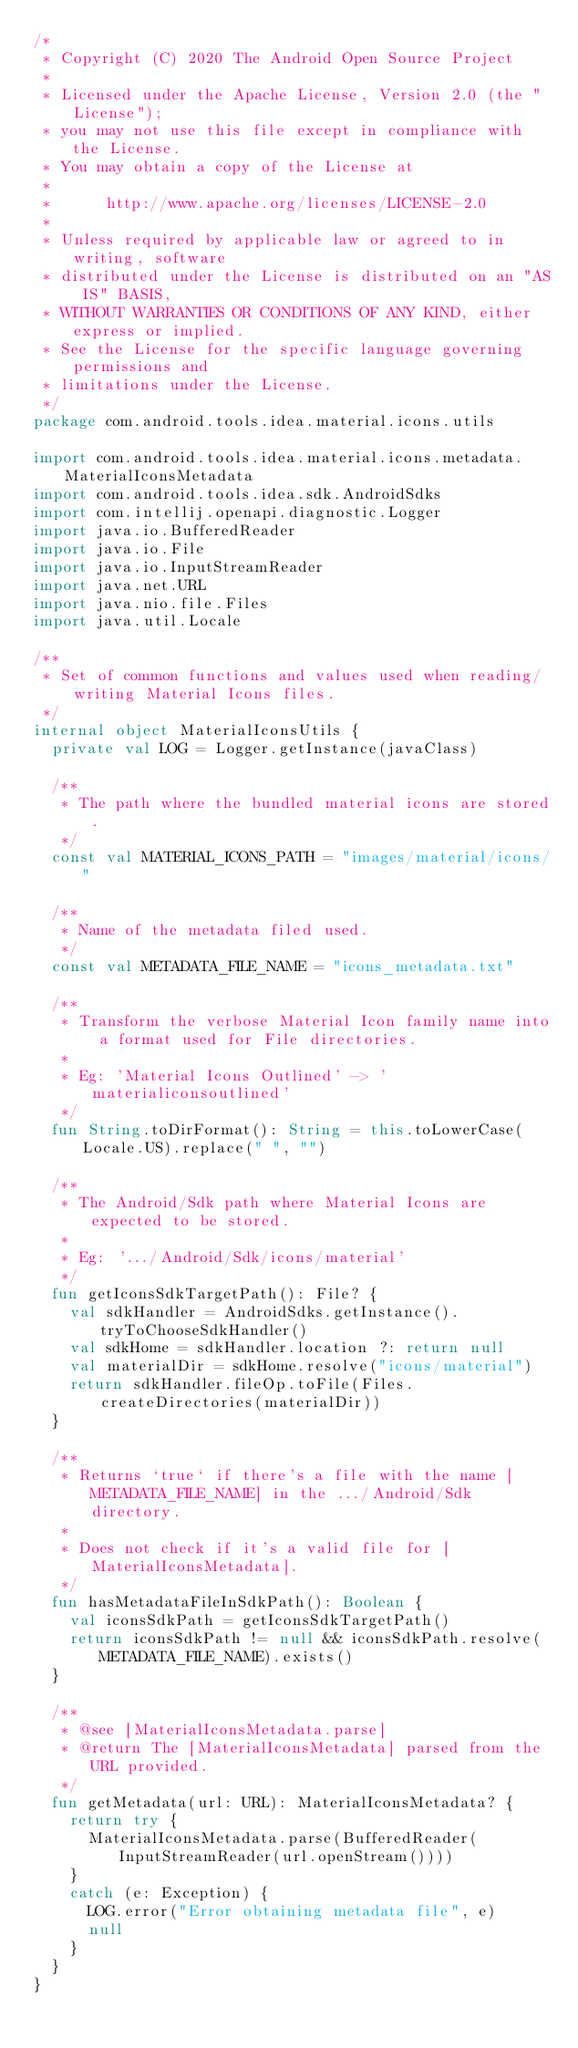Convert code to text. <code><loc_0><loc_0><loc_500><loc_500><_Kotlin_>/*
 * Copyright (C) 2020 The Android Open Source Project
 *
 * Licensed under the Apache License, Version 2.0 (the "License");
 * you may not use this file except in compliance with the License.
 * You may obtain a copy of the License at
 *
 *      http://www.apache.org/licenses/LICENSE-2.0
 *
 * Unless required by applicable law or agreed to in writing, software
 * distributed under the License is distributed on an "AS IS" BASIS,
 * WITHOUT WARRANTIES OR CONDITIONS OF ANY KIND, either express or implied.
 * See the License for the specific language governing permissions and
 * limitations under the License.
 */
package com.android.tools.idea.material.icons.utils

import com.android.tools.idea.material.icons.metadata.MaterialIconsMetadata
import com.android.tools.idea.sdk.AndroidSdks
import com.intellij.openapi.diagnostic.Logger
import java.io.BufferedReader
import java.io.File
import java.io.InputStreamReader
import java.net.URL
import java.nio.file.Files
import java.util.Locale

/**
 * Set of common functions and values used when reading/writing Material Icons files.
 */
internal object MaterialIconsUtils {
  private val LOG = Logger.getInstance(javaClass)

  /**
   * The path where the bundled material icons are stored.
   */
  const val MATERIAL_ICONS_PATH = "images/material/icons/"

  /**
   * Name of the metadata filed used.
   */
  const val METADATA_FILE_NAME = "icons_metadata.txt"

  /**
   * Transform the verbose Material Icon family name into a format used for File directories.
   *
   * Eg: 'Material Icons Outlined' -> 'materialiconsoutlined'
   */
  fun String.toDirFormat(): String = this.toLowerCase(Locale.US).replace(" ", "")

  /**
   * The Android/Sdk path where Material Icons are expected to be stored.
   *
   * Eg: '.../Android/Sdk/icons/material'
   */
  fun getIconsSdkTargetPath(): File? {
    val sdkHandler = AndroidSdks.getInstance().tryToChooseSdkHandler()
    val sdkHome = sdkHandler.location ?: return null
    val materialDir = sdkHome.resolve("icons/material")
    return sdkHandler.fileOp.toFile(Files.createDirectories(materialDir))
  }

  /**
   * Returns `true` if there's a file with the name [METADATA_FILE_NAME] in the .../Android/Sdk directory.
   *
   * Does not check if it's a valid file for [MaterialIconsMetadata].
   */
  fun hasMetadataFileInSdkPath(): Boolean {
    val iconsSdkPath = getIconsSdkTargetPath()
    return iconsSdkPath != null && iconsSdkPath.resolve(METADATA_FILE_NAME).exists()
  }

  /**
   * @see [MaterialIconsMetadata.parse]
   * @return The [MaterialIconsMetadata] parsed from the URL provided.
   */
  fun getMetadata(url: URL): MaterialIconsMetadata? {
    return try {
      MaterialIconsMetadata.parse(BufferedReader(InputStreamReader(url.openStream())))
    }
    catch (e: Exception) {
      LOG.error("Error obtaining metadata file", e)
      null
    }
  }
}</code> 